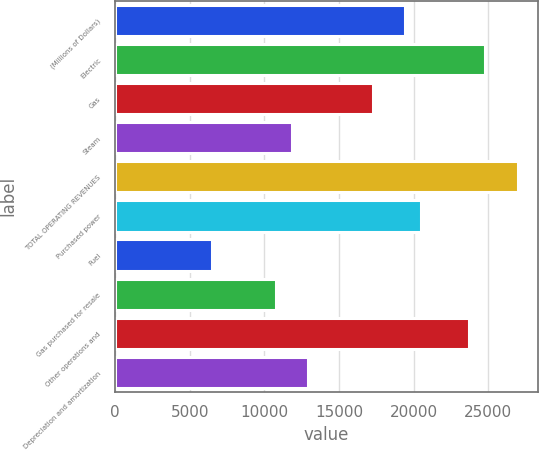Convert chart. <chart><loc_0><loc_0><loc_500><loc_500><bar_chart><fcel>(Millions of Dollars)<fcel>Electric<fcel>Gas<fcel>Steam<fcel>TOTAL OPERATING REVENUES<fcel>Purchased power<fcel>Fuel<fcel>Gas purchased for resale<fcel>Other operations and<fcel>Depreciation and amortization<nl><fcel>19414<fcel>24806.5<fcel>17257<fcel>11864.5<fcel>26963.5<fcel>20492.5<fcel>6472<fcel>10786<fcel>23728<fcel>12943<nl></chart> 